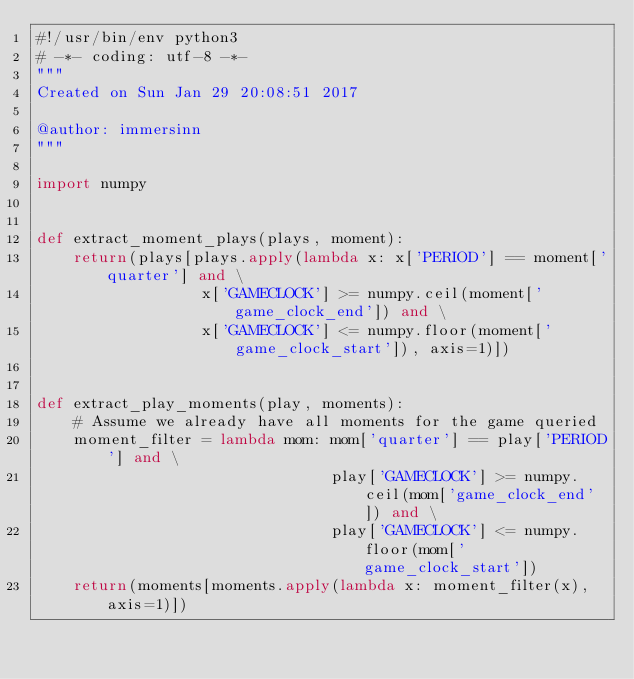<code> <loc_0><loc_0><loc_500><loc_500><_Python_>#!/usr/bin/env python3
# -*- coding: utf-8 -*-
"""
Created on Sun Jan 29 20:08:51 2017

@author: immersinn
"""

import numpy


def extract_moment_plays(plays, moment):
    return(plays[plays.apply(lambda x: x['PERIOD'] == moment['quarter'] and \
                  x['GAMECLOCK'] >= numpy.ceil(moment['game_clock_end']) and \
                  x['GAMECLOCK'] <= numpy.floor(moment['game_clock_start']), axis=1)])
    
    
def extract_play_moments(play, moments):
    # Assume we already have all moments for the game queried
    moment_filter = lambda mom: mom['quarter'] == play['PERIOD'] and \
                                play['GAMECLOCK'] >= numpy.ceil(mom['game_clock_end']) and \
                                play['GAMECLOCK'] <= numpy.floor(mom['game_clock_start'])
    return(moments[moments.apply(lambda x: moment_filter(x), axis=1)])</code> 